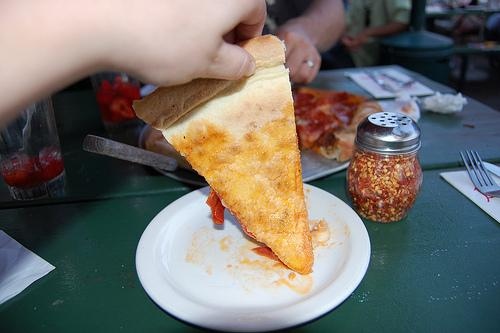Identify the ring on the person's hand, and describe the action of the hand in the image. There is a ring on the person's left hand, which is holding a slice of pizza almost upside down. In a single sentence, describe what is happening in the restaurant scene. A person is holding a slice of pizza above a white plate on a green table, while other items such as a pepper shaker, fork, white napkin, and a glass are present. Mention the color of liquid in the drinking glass and the type of seasoning in the shaker. The liquid in the drinking glass is red, and the shaker has red pepper flakes in it. What is the color of the tabletop and what kind of food is on it? The tabletop is green and there is pizza on it. Describe the position of the fork and the napkin in relation to each other. The fork is laying on a white napkin, which is under it on the green table. What type of silverware and table items can be found in the image besides the pizza? A fork, a white napkin, a pepper shaker with a silver top, and a glass of beverage can be found on the table. Describe the appearance of the shaker and its contents. The shaker is a glass jar with a silver perforated top, containing red pepper flakes as seasoning. Name the ingredients that can be found on the pizza in this image. The pizza has cheese and tomato sauce as visible ingredients. What unique feature can be found on the bottom of the pizza in the image? There are toppings sliding off the bottom of the pizza slice. Explain the state of the pizza slice being held by the person in the image. The held pizza slice is cooked or baked, with cheese and tomato sauce as toppings, and is being held almost upside down. 